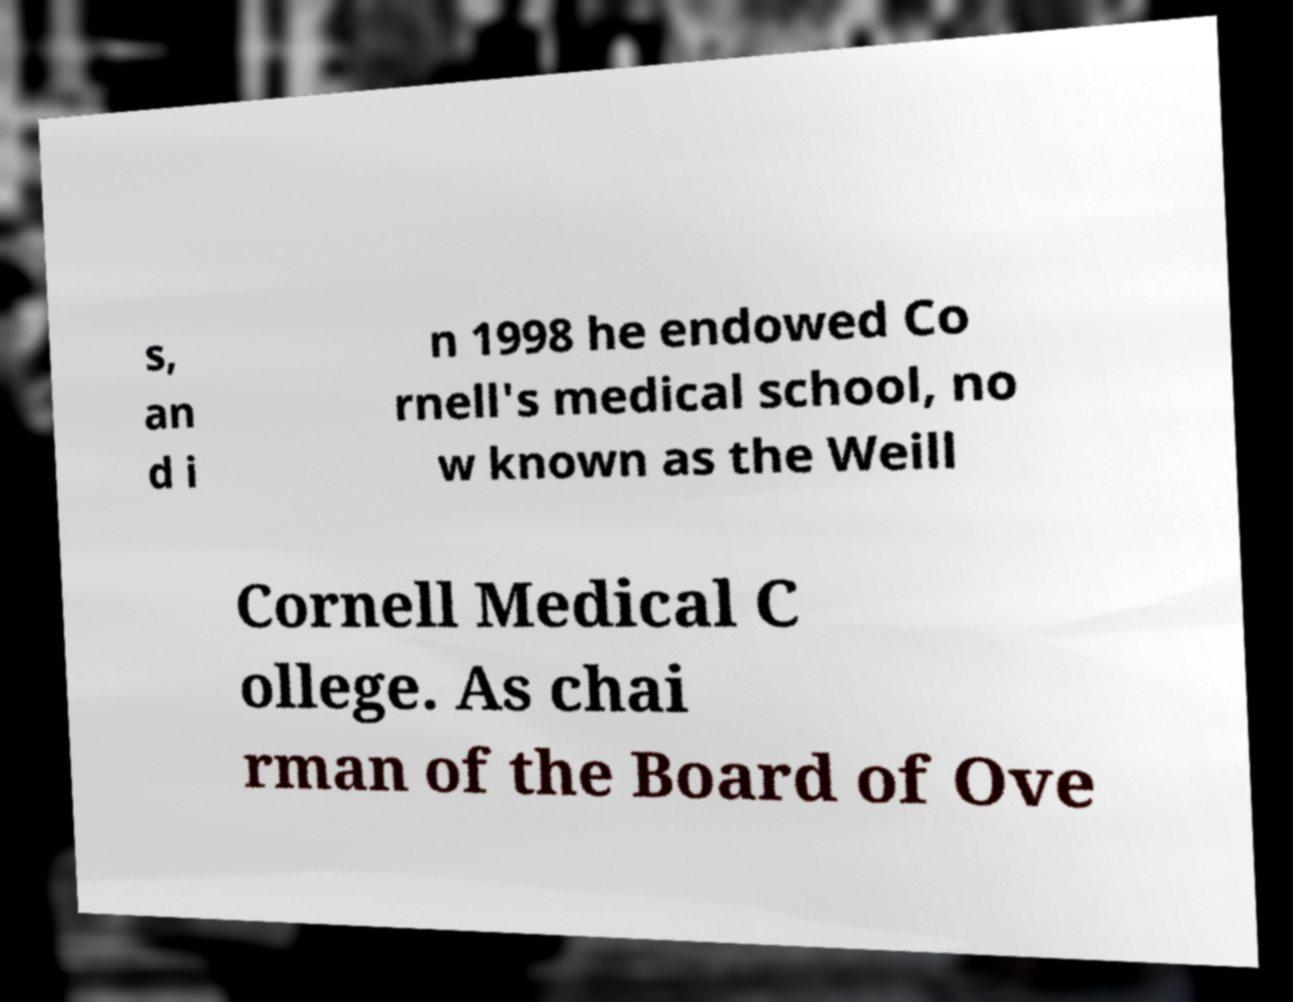What messages or text are displayed in this image? I need them in a readable, typed format. s, an d i n 1998 he endowed Co rnell's medical school, no w known as the Weill Cornell Medical C ollege. As chai rman of the Board of Ove 